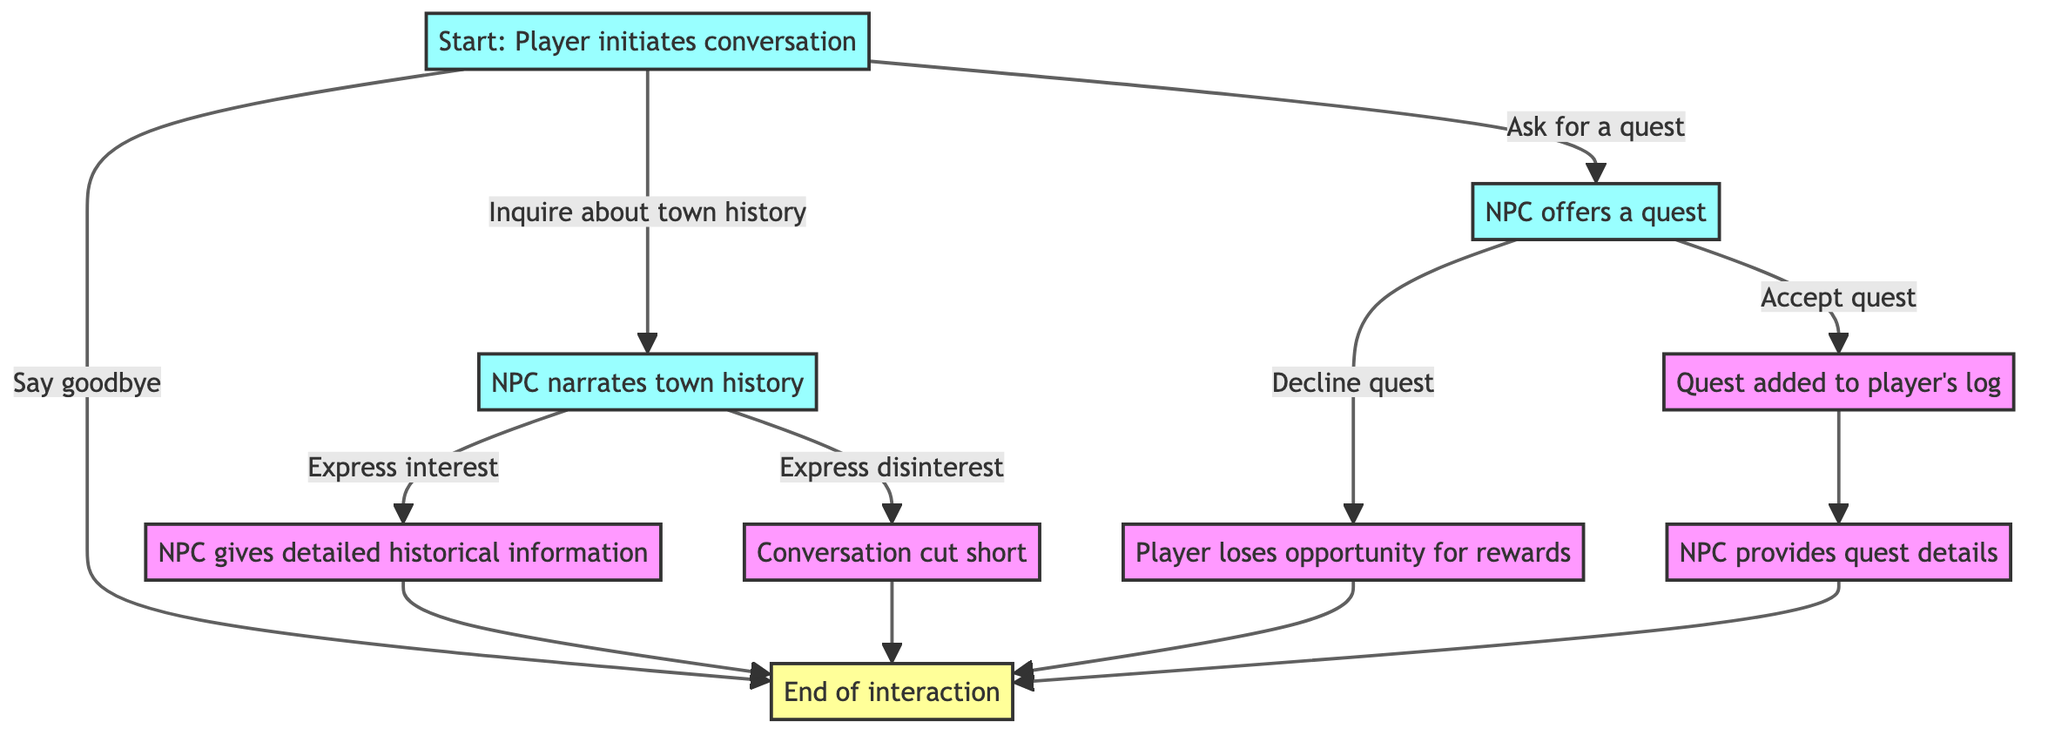What is the first action a player can take in the interaction? The diagram shows that the first action a player can take is to initiate a conversation with the NPC, which is represented as the starting node.
Answer: Player initiates conversation How many choices does the player have when starting the interaction? The diagram indicates there are three choices available to the player when initiating the interaction: inquire about town history, ask for a quest, or say goodbye.
Answer: Three choices What happens if the player expresses interest in the town history? According to the diagram, if the player expresses interest, the NPC provides detailed historical information or a relic, which benefits the player by enhancing their understanding of the lore and potentially provides an item.
Answer: Player gains deeper understanding of lore and possibly a relic What is the consequence of declining the quest? The diagram states that if the player declines the quest, they lose the opportunity for potential rewards, meaning they miss out on any benefits associated with that quest.
Answer: Player loses opportunity for potential rewards After accepting the quest, what is the next step in the interaction? The diagram outlines that upon accepting the quest, the next step is that the NPC provides quest details, indicating that the flow continues with further information related to the quest.
Answer: NPC provides quest details If the player chooses to inquire about town history, what can they choose next? The diagram shows that after inquiring about town history, the player then has the option to express interest or express disinterest, which are the subsequent player responses in that branch.
Answer: Express interest or express disinterest What is the final step in the interaction after any of the branches? The diagram indicates that after every branch, including the acceptance of a quest or expressing interest or disinterest in town history, the interaction ultimately leads to the end of the conversation.
Answer: End of interaction What does expressing disinterest lead to? The diagram specifies that if the player expresses disinterest, the NPC becomes disappointed and the conversation is cut short, culminating in a missed opportunity for lore and items.
Answer: Player misses out on lore and a potential item 